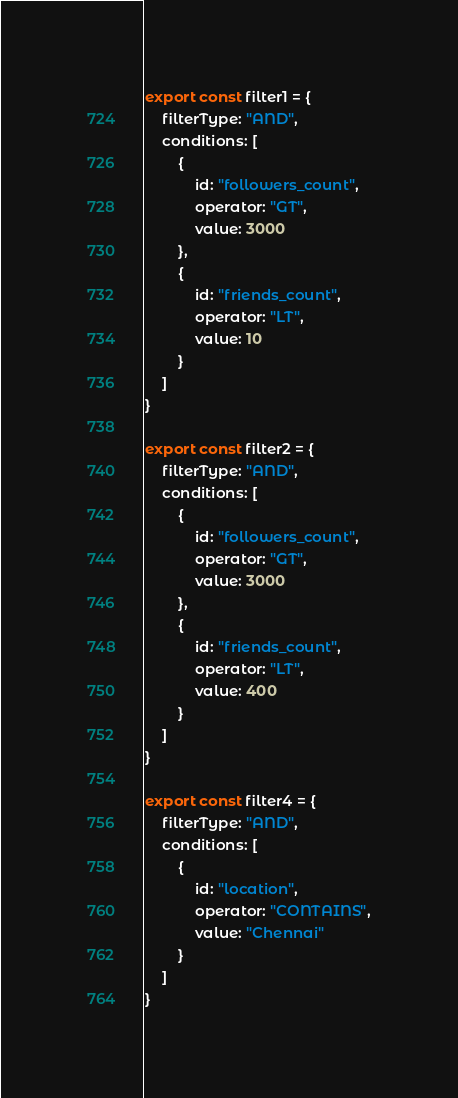Convert code to text. <code><loc_0><loc_0><loc_500><loc_500><_TypeScript_>export const filter1 = {
    filterType: "AND",
    conditions: [
        {
            id: "followers_count",
            operator: "GT",
            value: 3000
        },
        {
            id: "friends_count",
            operator: "LT",
            value: 10
        }
    ]
}

export const filter2 = {
    filterType: "AND",
    conditions: [
        {
            id: "followers_count",
            operator: "GT",
            value: 3000
        },
        {
            id: "friends_count",
            operator: "LT",
            value: 400
        }
    ]
}

export const filter4 = {
    filterType: "AND",
    conditions: [
        {
            id: "location",
            operator: "CONTAINS",
            value: "Chennai"
        }
    ]
}</code> 